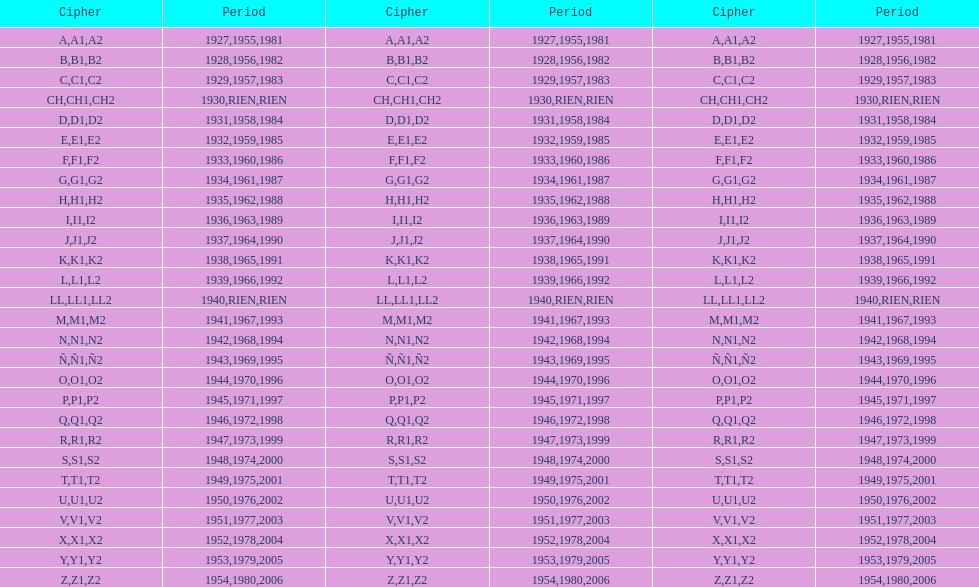List each code not associated to a year. CH1, CH2, LL1, LL2. 